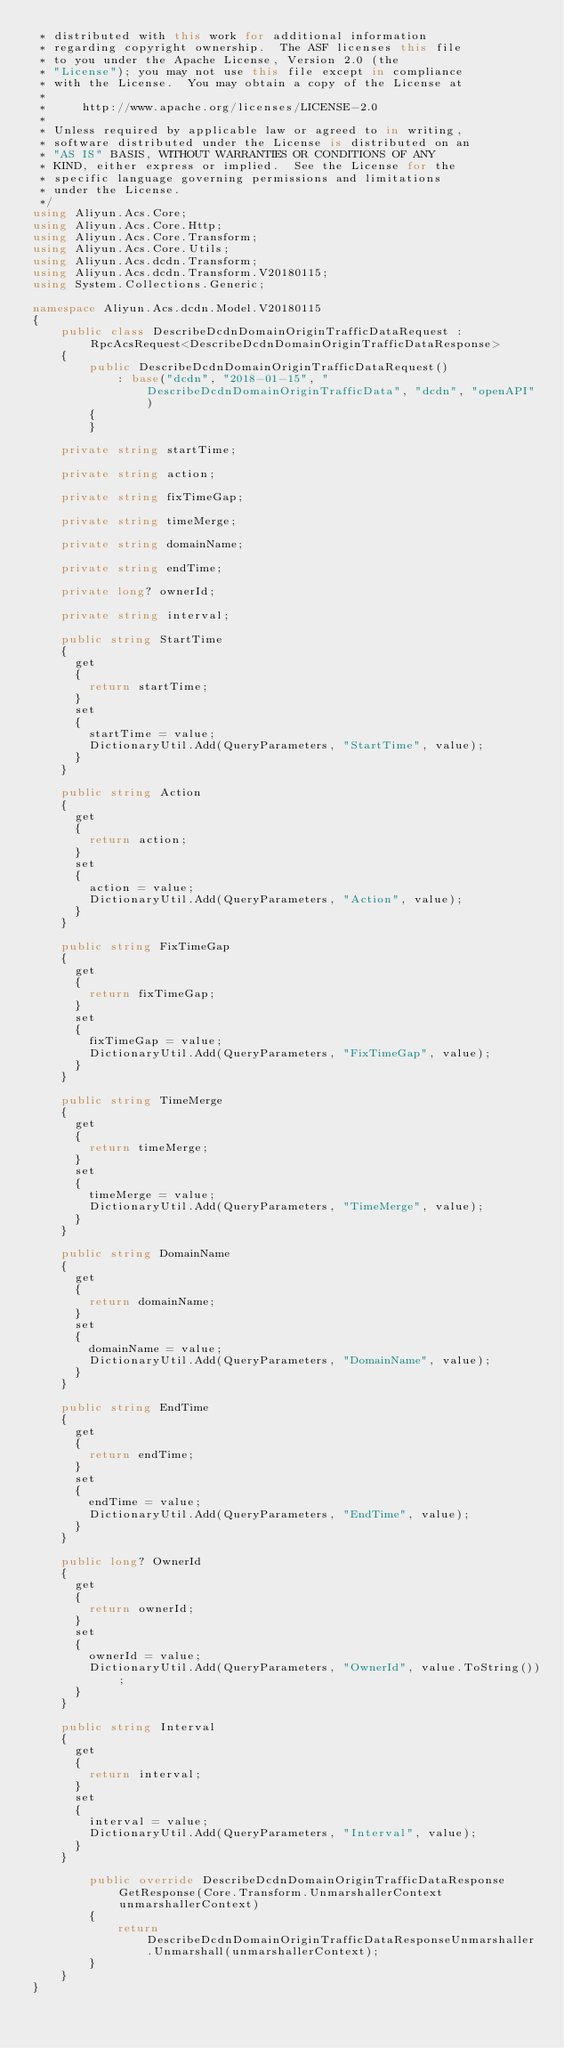<code> <loc_0><loc_0><loc_500><loc_500><_C#_> * distributed with this work for additional information
 * regarding copyright ownership.  The ASF licenses this file
 * to you under the Apache License, Version 2.0 (the
 * "License"); you may not use this file except in compliance
 * with the License.  You may obtain a copy of the License at
 *
 *     http://www.apache.org/licenses/LICENSE-2.0
 *
 * Unless required by applicable law or agreed to in writing,
 * software distributed under the License is distributed on an
 * "AS IS" BASIS, WITHOUT WARRANTIES OR CONDITIONS OF ANY
 * KIND, either express or implied.  See the License for the
 * specific language governing permissions and limitations
 * under the License.
 */
using Aliyun.Acs.Core;
using Aliyun.Acs.Core.Http;
using Aliyun.Acs.Core.Transform;
using Aliyun.Acs.Core.Utils;
using Aliyun.Acs.dcdn.Transform;
using Aliyun.Acs.dcdn.Transform.V20180115;
using System.Collections.Generic;

namespace Aliyun.Acs.dcdn.Model.V20180115
{
    public class DescribeDcdnDomainOriginTrafficDataRequest : RpcAcsRequest<DescribeDcdnDomainOriginTrafficDataResponse>
    {
        public DescribeDcdnDomainOriginTrafficDataRequest()
            : base("dcdn", "2018-01-15", "DescribeDcdnDomainOriginTrafficData", "dcdn", "openAPI")
        {
        }

		private string startTime;

		private string action;

		private string fixTimeGap;

		private string timeMerge;

		private string domainName;

		private string endTime;

		private long? ownerId;

		private string interval;

		public string StartTime
		{
			get
			{
				return startTime;
			}
			set	
			{
				startTime = value;
				DictionaryUtil.Add(QueryParameters, "StartTime", value);
			}
		}

		public string Action
		{
			get
			{
				return action;
			}
			set	
			{
				action = value;
				DictionaryUtil.Add(QueryParameters, "Action", value);
			}
		}

		public string FixTimeGap
		{
			get
			{
				return fixTimeGap;
			}
			set	
			{
				fixTimeGap = value;
				DictionaryUtil.Add(QueryParameters, "FixTimeGap", value);
			}
		}

		public string TimeMerge
		{
			get
			{
				return timeMerge;
			}
			set	
			{
				timeMerge = value;
				DictionaryUtil.Add(QueryParameters, "TimeMerge", value);
			}
		}

		public string DomainName
		{
			get
			{
				return domainName;
			}
			set	
			{
				domainName = value;
				DictionaryUtil.Add(QueryParameters, "DomainName", value);
			}
		}

		public string EndTime
		{
			get
			{
				return endTime;
			}
			set	
			{
				endTime = value;
				DictionaryUtil.Add(QueryParameters, "EndTime", value);
			}
		}

		public long? OwnerId
		{
			get
			{
				return ownerId;
			}
			set	
			{
				ownerId = value;
				DictionaryUtil.Add(QueryParameters, "OwnerId", value.ToString());
			}
		}

		public string Interval
		{
			get
			{
				return interval;
			}
			set	
			{
				interval = value;
				DictionaryUtil.Add(QueryParameters, "Interval", value);
			}
		}

        public override DescribeDcdnDomainOriginTrafficDataResponse GetResponse(Core.Transform.UnmarshallerContext unmarshallerContext)
        {
            return DescribeDcdnDomainOriginTrafficDataResponseUnmarshaller.Unmarshall(unmarshallerContext);
        }
    }
}</code> 